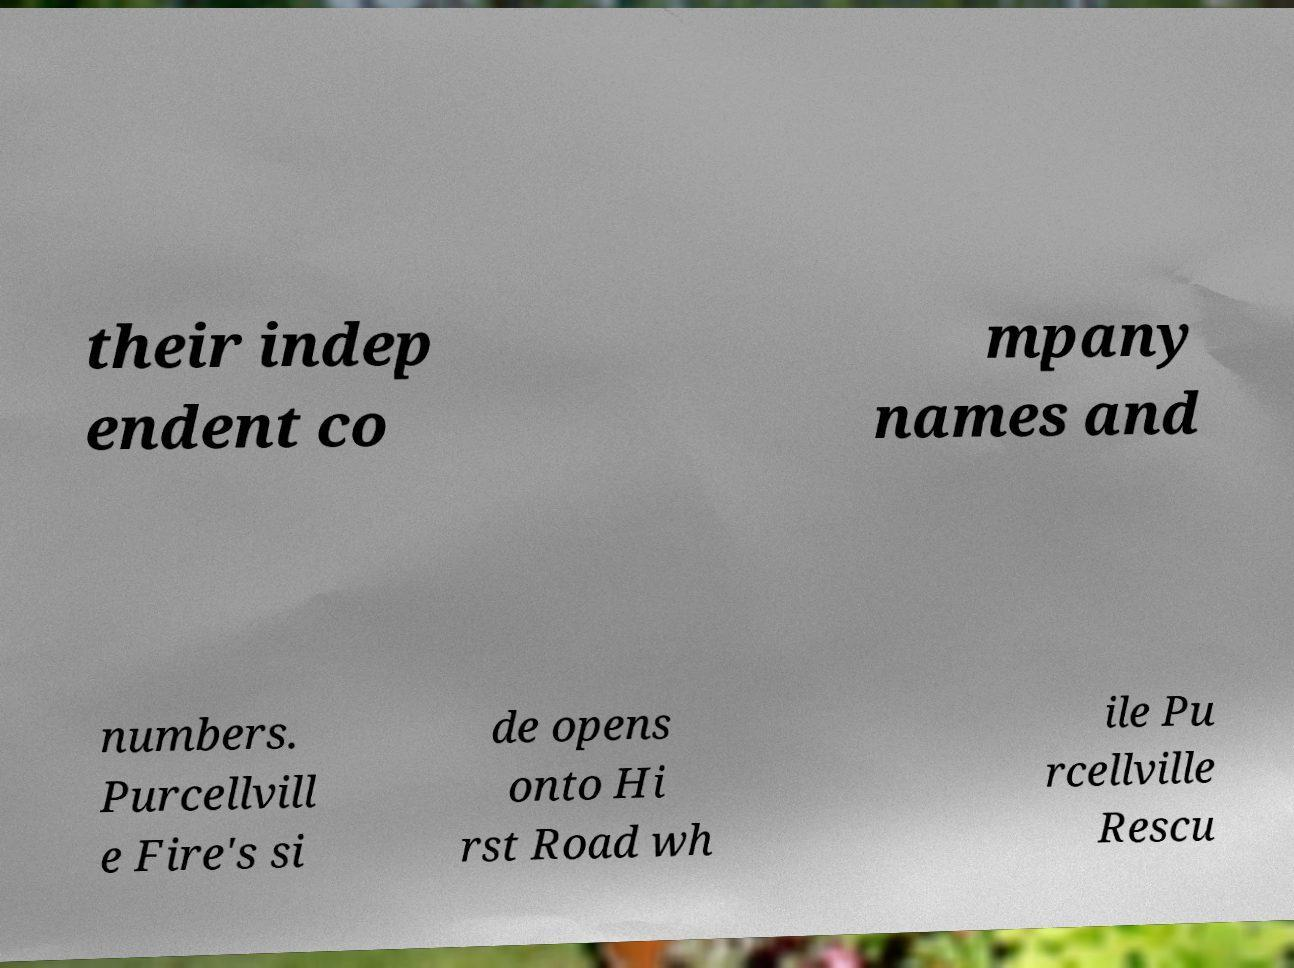Can you read and provide the text displayed in the image?This photo seems to have some interesting text. Can you extract and type it out for me? their indep endent co mpany names and numbers. Purcellvill e Fire's si de opens onto Hi rst Road wh ile Pu rcellville Rescu 